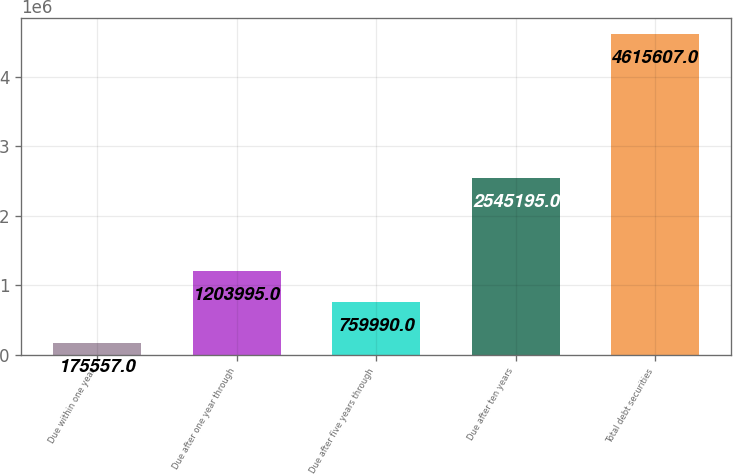Convert chart to OTSL. <chart><loc_0><loc_0><loc_500><loc_500><bar_chart><fcel>Due within one year<fcel>Due after one year through<fcel>Due after five years through<fcel>Due after ten years<fcel>Total debt securities<nl><fcel>175557<fcel>1.204e+06<fcel>759990<fcel>2.5452e+06<fcel>4.61561e+06<nl></chart> 